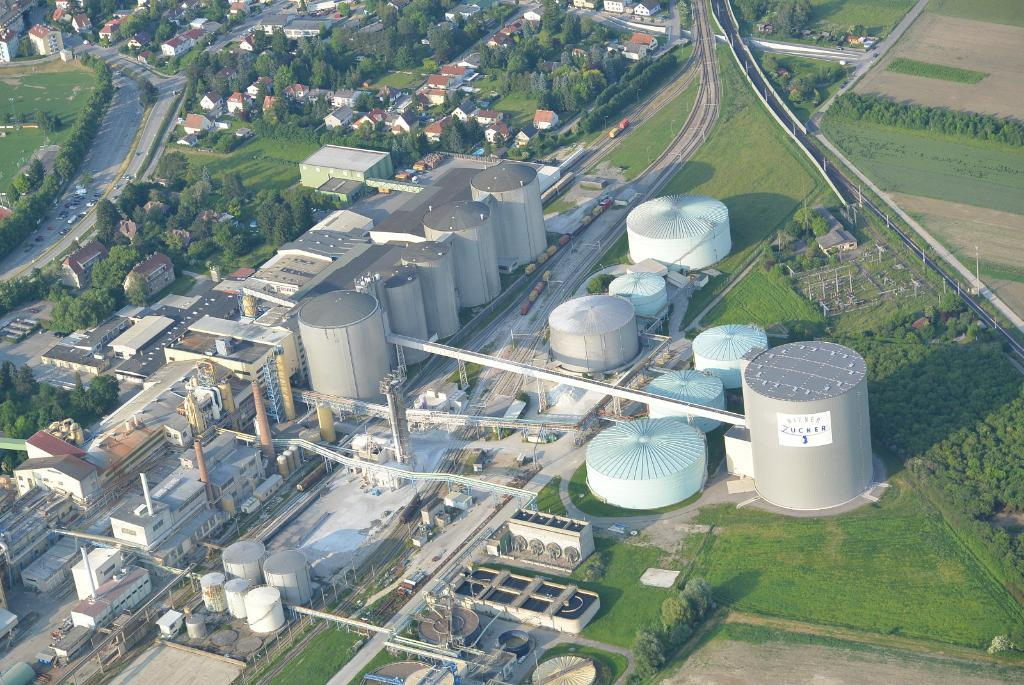What type of structures can be seen in the image? There are buildings and houses in the image. What type of natural environment is visible in the image? There is grass and trees visible in the image. What type of transportation is present on the road in the image? There are vehicles on the road in the image. Can you see any steam coming from the trees in the image? There is no steam visible in the image, as it features buildings, houses, grass, trees, and vehicles. What is the cause of the buildings in the image? The cause of the buildings in the image cannot be determined from the image itself. 